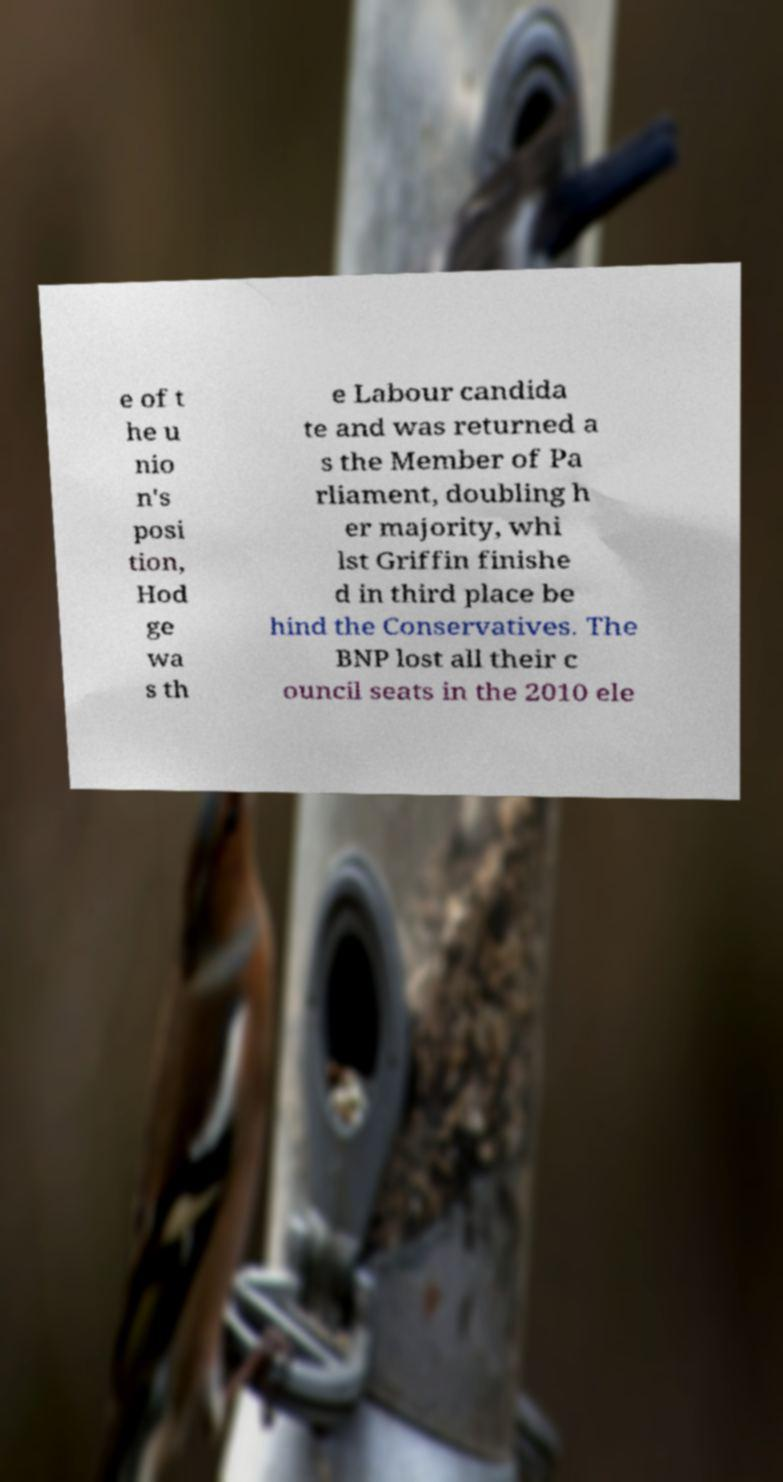What messages or text are displayed in this image? I need them in a readable, typed format. e of t he u nio n's posi tion, Hod ge wa s th e Labour candida te and was returned a s the Member of Pa rliament, doubling h er majority, whi lst Griffin finishe d in third place be hind the Conservatives. The BNP lost all their c ouncil seats in the 2010 ele 